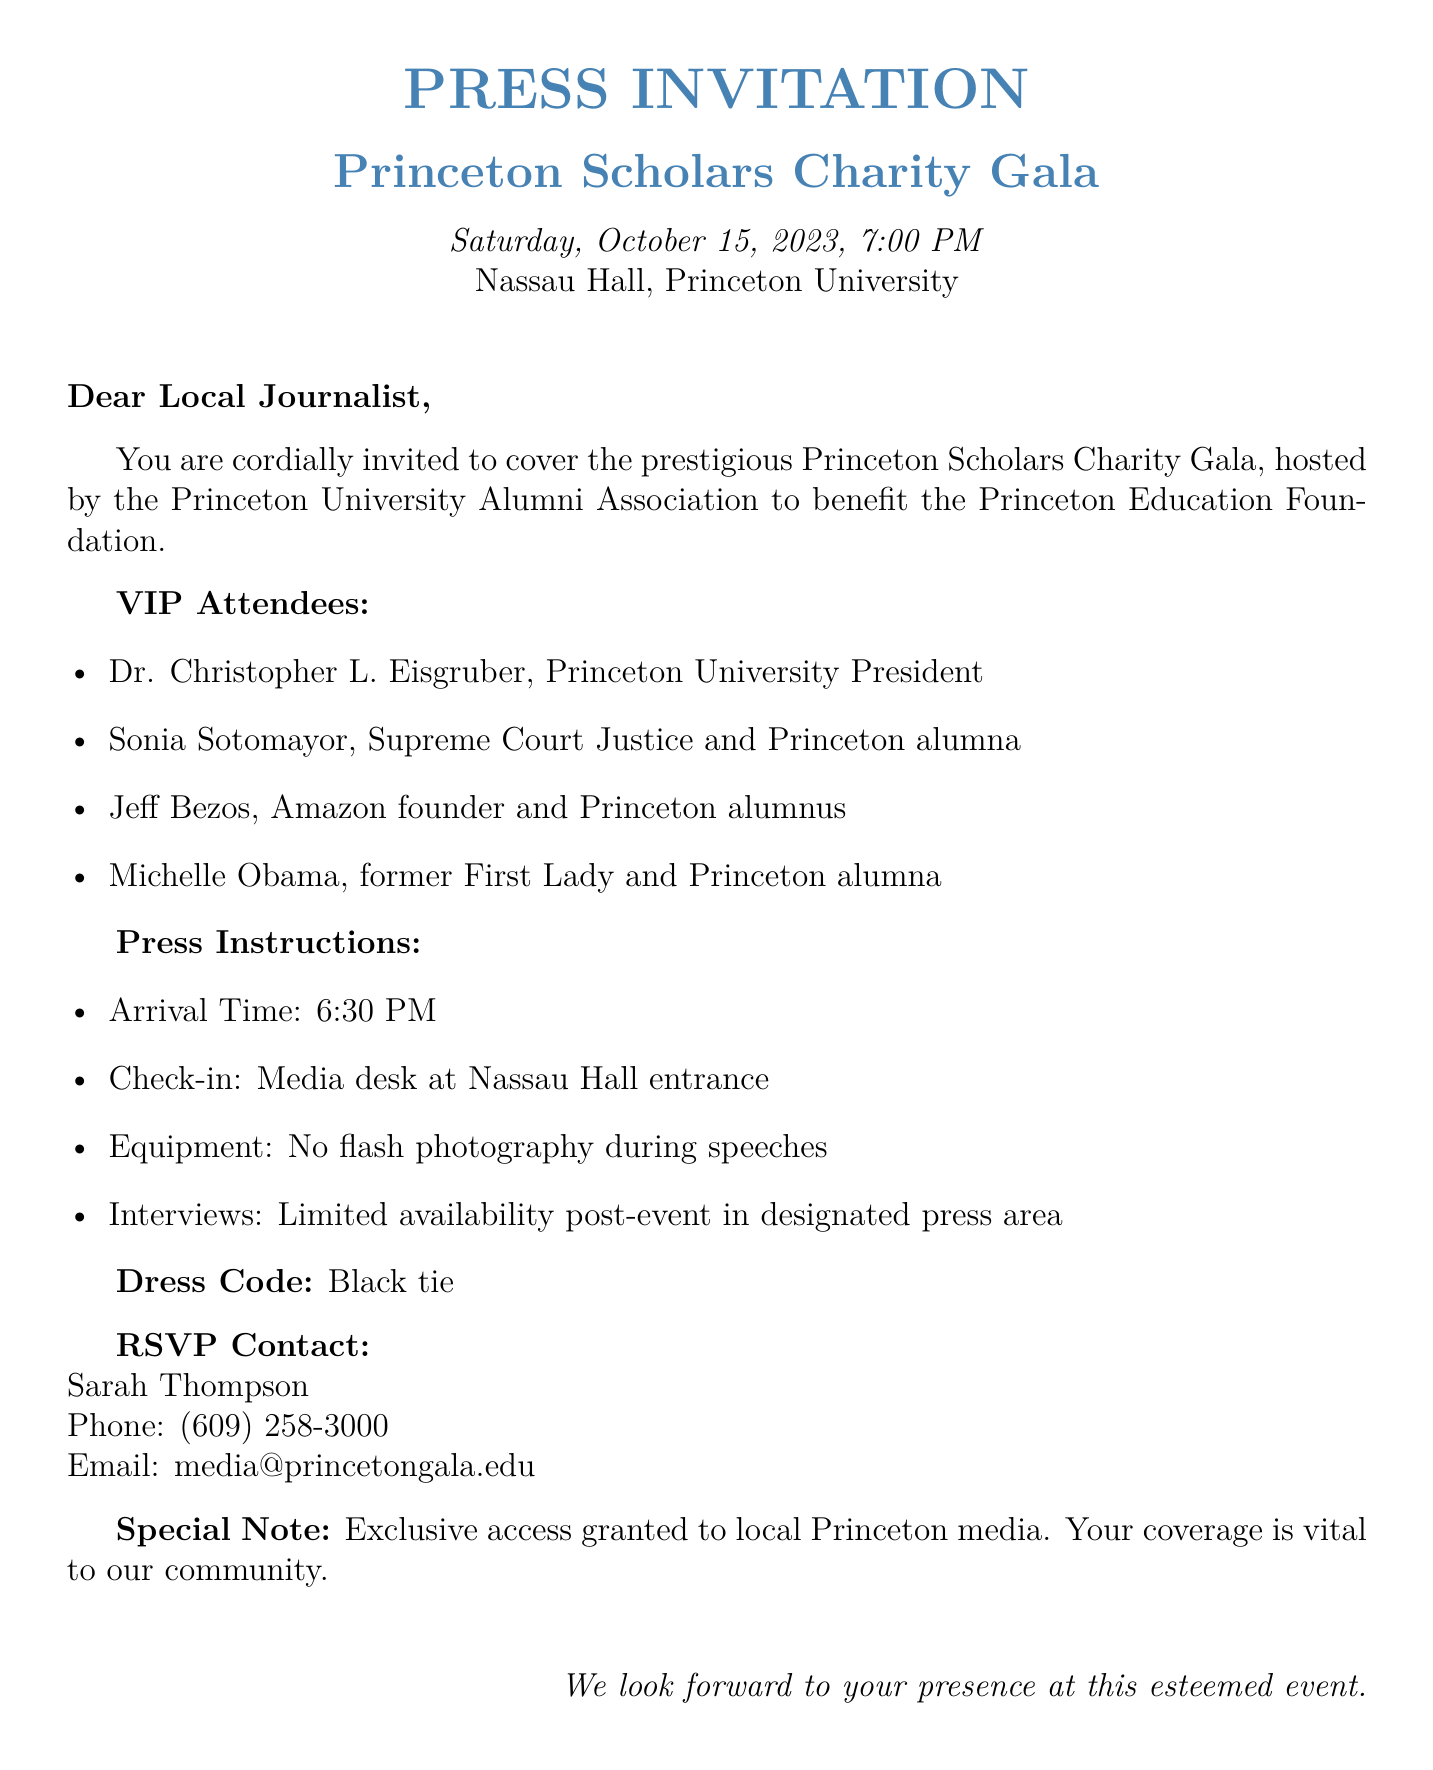What is the date of the gala? The gala is scheduled for Saturday, October 15, 2023.
Answer: October 15, 2023 Who is the president of Princeton University? The VIP attendee listed as the president of Princeton University is Dr. Christopher L. Eisgruber.
Answer: Dr. Christopher L. Eisgruber What is the dress code for the event? The document specifies that the dress code for the gala is black tie.
Answer: Black tie What time should press members arrive? The document indicates that press members should arrive at 6:30 PM.
Answer: 6:30 PM Who is the RSVP contact person? The RSVP contact person mentioned in the document is Sarah Thompson.
Answer: Sarah Thompson What equipment restriction is mentioned for the event? The document states that no flash photography is allowed during speeches.
Answer: No flash photography during speeches How many VIP attendees are named in the document? There are four VIP attendees listed in the document.
Answer: Four Where should media check in upon arrival? The check-in location for the media is at the media desk at the Nassau Hall entrance.
Answer: Media desk at Nassau Hall entrance What type of event is this invitation for? This faxed invitation is for a high-profile charity gala.
Answer: Charity gala 